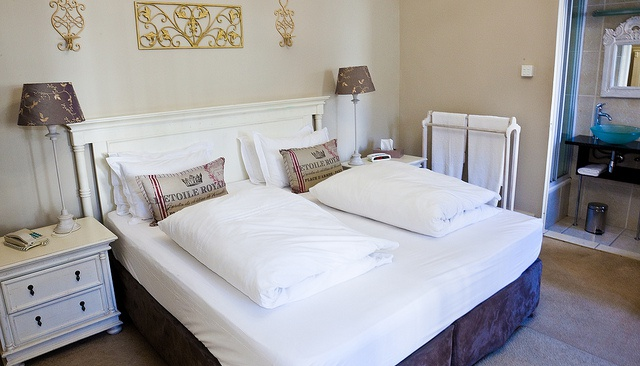Describe the objects in this image and their specific colors. I can see bed in darkgray, lightgray, black, and gray tones and sink in darkgray, blue, teal, black, and gray tones in this image. 